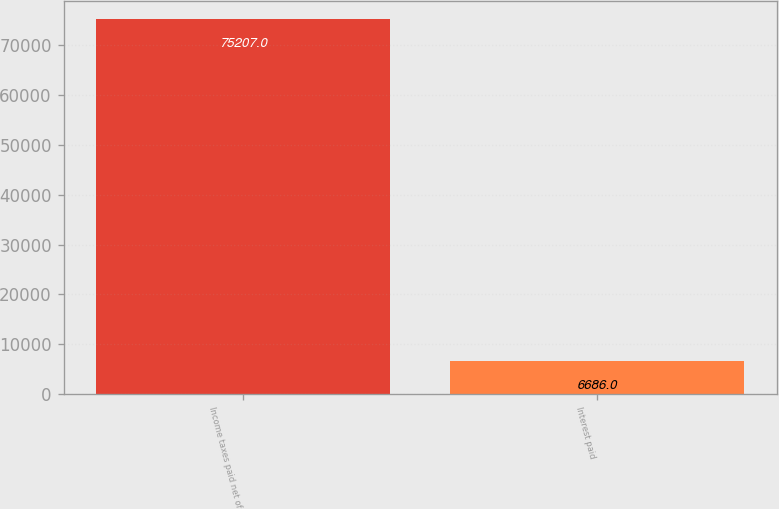<chart> <loc_0><loc_0><loc_500><loc_500><bar_chart><fcel>Income taxes paid net of<fcel>Interest paid<nl><fcel>75207<fcel>6686<nl></chart> 